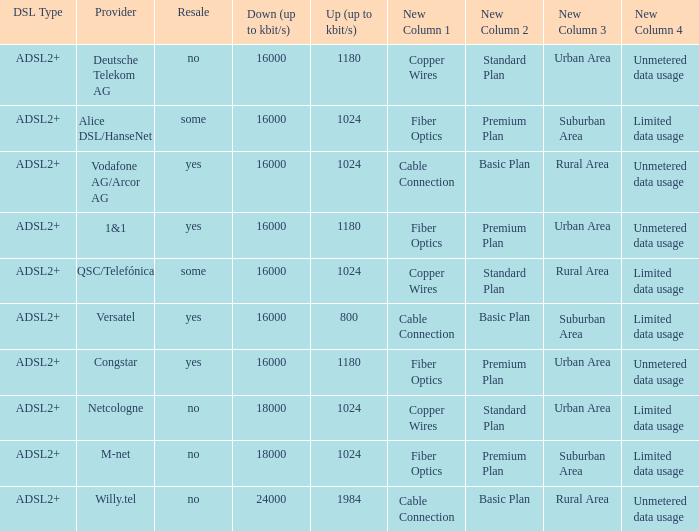What is the resale category for the provider NetCologne? No. Would you be able to parse every entry in this table? {'header': ['DSL Type', 'Provider', 'Resale', 'Down (up to kbit/s)', 'Up (up to kbit/s)', 'New Column 1', 'New Column 2', 'New Column 3', 'New Column 4 '], 'rows': [['ADSL2+', 'Deutsche Telekom AG', 'no', '16000', '1180', 'Copper Wires', 'Standard Plan', 'Urban Area', 'Unmetered data usage '], ['ADSL2+', 'Alice DSL/HanseNet', 'some', '16000', '1024', 'Fiber Optics', 'Premium Plan', 'Suburban Area', 'Limited data usage '], ['ADSL2+', 'Vodafone AG/Arcor AG', 'yes', '16000', '1024', 'Cable Connection', 'Basic Plan', 'Rural Area', 'Unmetered data usage '], ['ADSL2+', '1&1', 'yes', '16000', '1180', 'Fiber Optics', 'Premium Plan', 'Urban Area', 'Unmetered data usage '], ['ADSL2+', 'QSC/Telefónica', 'some', '16000', '1024', 'Copper Wires', 'Standard Plan', 'Rural Area', 'Limited data usage '], ['ADSL2+', 'Versatel', 'yes', '16000', '800', 'Cable Connection', 'Basic Plan', 'Suburban Area', 'Limited data usage '], ['ADSL2+', 'Congstar', 'yes', '16000', '1180', 'Fiber Optics', 'Premium Plan', 'Urban Area', 'Unmetered data usage '], ['ADSL2+', 'Netcologne', 'no', '18000', '1024', 'Copper Wires', 'Standard Plan', 'Urban Area', 'Limited data usage '], ['ADSL2+', 'M-net', 'no', '18000', '1024', 'Fiber Optics', 'Premium Plan', 'Suburban Area', 'Limited data usage '], ['ADSL2+', 'Willy.tel', 'no', '24000', '1984', 'Cable Connection', 'Basic Plan', 'Rural Area', 'Unmetered data usage']]} 